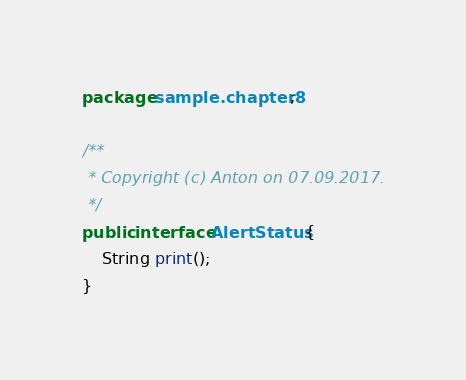Convert code to text. <code><loc_0><loc_0><loc_500><loc_500><_Java_>package sample.chapter8;

/**
 * Copyright (c) Anton on 07.09.2017.
 */
public interface AlertStatus {
    String print();
}
</code> 